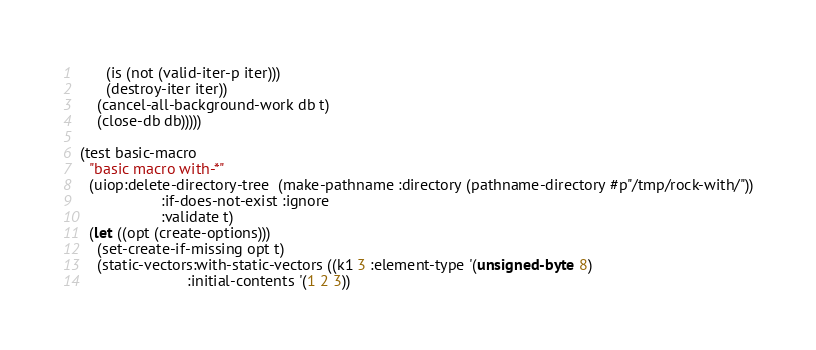Convert code to text. <code><loc_0><loc_0><loc_500><loc_500><_Lisp_>	  (is (not (valid-iter-p iter)))
	  (destroy-iter iter))
	(cancel-all-background-work db t)
	(close-db db)))))

(test basic-macro
  "basic macro with-*"
  (uiop:delete-directory-tree  (make-pathname :directory (pathname-directory #p"/tmp/rock-with/"))
			       :if-does-not-exist :ignore
			       :validate t)
  (let ((opt (create-options)))
    (set-create-if-missing opt t)
    (static-vectors:with-static-vectors ((k1 3 :element-type '(unsigned-byte 8)
					     :initial-contents '(1 2 3))</code> 